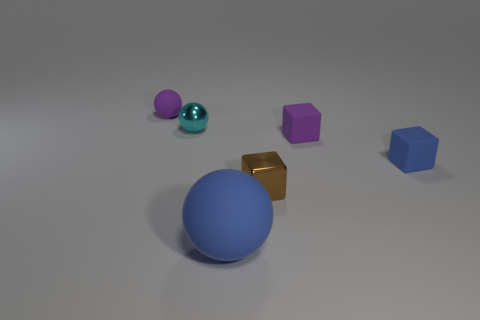Is there anything else that has the same size as the blue rubber sphere?
Keep it short and to the point. No. The matte object that is both to the left of the small purple rubber cube and in front of the tiny cyan ball is what color?
Ensure brevity in your answer.  Blue. How many other objects are the same shape as the small cyan metallic thing?
Provide a succinct answer. 2. Are there fewer large blue rubber balls that are on the right side of the big blue sphere than small blue cubes that are to the right of the tiny purple rubber cube?
Your answer should be compact. Yes. Do the brown block and the small object that is to the left of the tiny cyan ball have the same material?
Give a very brief answer. No. Are there any other things that are made of the same material as the small purple cube?
Make the answer very short. Yes. Is the number of large things greater than the number of purple matte objects?
Give a very brief answer. No. What shape is the matte object behind the tiny sphere on the right side of the small purple rubber object left of the large blue rubber object?
Offer a terse response. Sphere. Is the purple object that is on the right side of the big blue rubber sphere made of the same material as the blue object that is on the left side of the tiny brown metallic object?
Provide a short and direct response. Yes. There is a tiny object that is the same material as the tiny brown cube; what is its shape?
Keep it short and to the point. Sphere. 